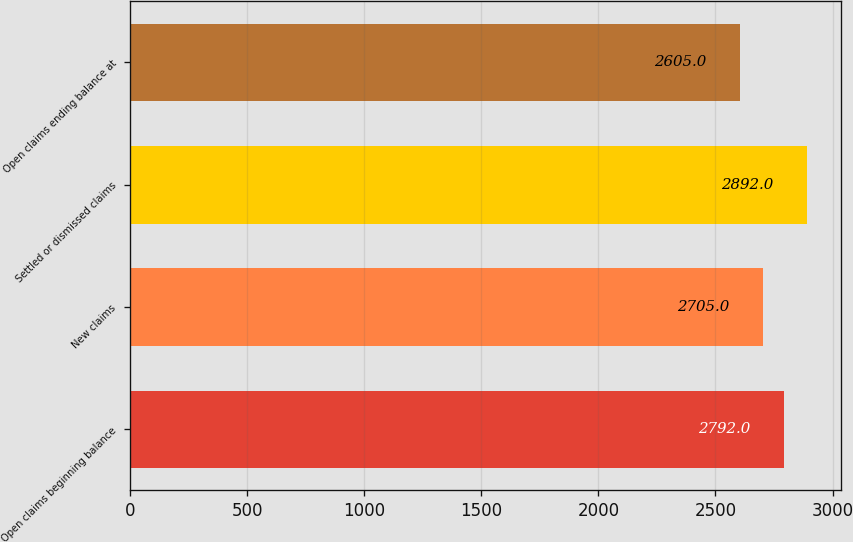Convert chart to OTSL. <chart><loc_0><loc_0><loc_500><loc_500><bar_chart><fcel>Open claims beginning balance<fcel>New claims<fcel>Settled or dismissed claims<fcel>Open claims ending balance at<nl><fcel>2792<fcel>2705<fcel>2892<fcel>2605<nl></chart> 